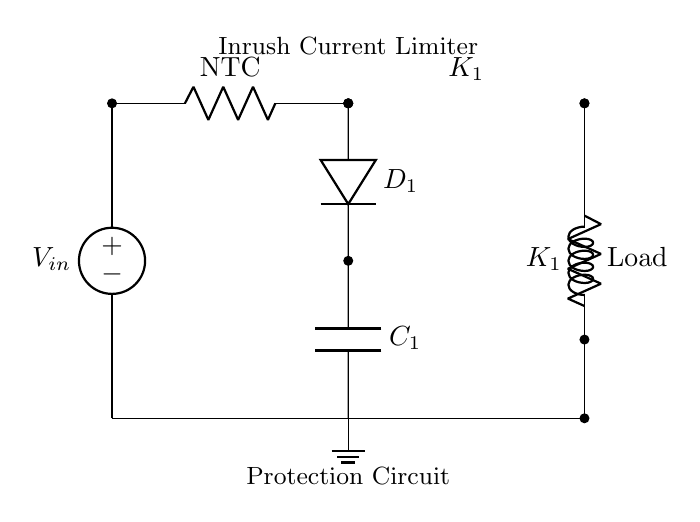What component is used for inrush current limiting? The circuit includes an NTC thermistor, which is designed to limit inrush current during startup due to its temperature-dependent resistance characteristics.
Answer: NTC thermistor What does the diode D1 do in this circuit? The diode D1 is placed in parallel with the NTC thermistor and allows current to bypass the thermistor during normal operation once it has heated up, thus protecting against excessive voltage drop across the thermistor.
Answer: Bypass current What is the function of the relay K1 in the circuit? The relay K1 serves to control the inrush current; it initially allows the current to flow through the thermistor and later disconnects the thermistor from the power supply after the initial surge.
Answer: Control inrush What happens to the capacitor C1 during startup? During the startup phase, the capacitor C1 charges up, absorbing some of the inrush current, while also providing a smoothing effect on the power supply voltage.
Answer: Absorbs inrush What is the voltage across the load after startup? After startup, the voltage across the load stabilizes at the supply voltage once the relay K1 disconnects the thermistor, eliminating its influence on the circuit.
Answer: Supply voltage Why is it important to protect power supplies from inrush current? Protecting power supplies from inrush current is crucial to prevent damage to components, ensure reliable operation, and avoid tripping circuit breakers due to excessive current draw at startup.
Answer: Prevent damage 